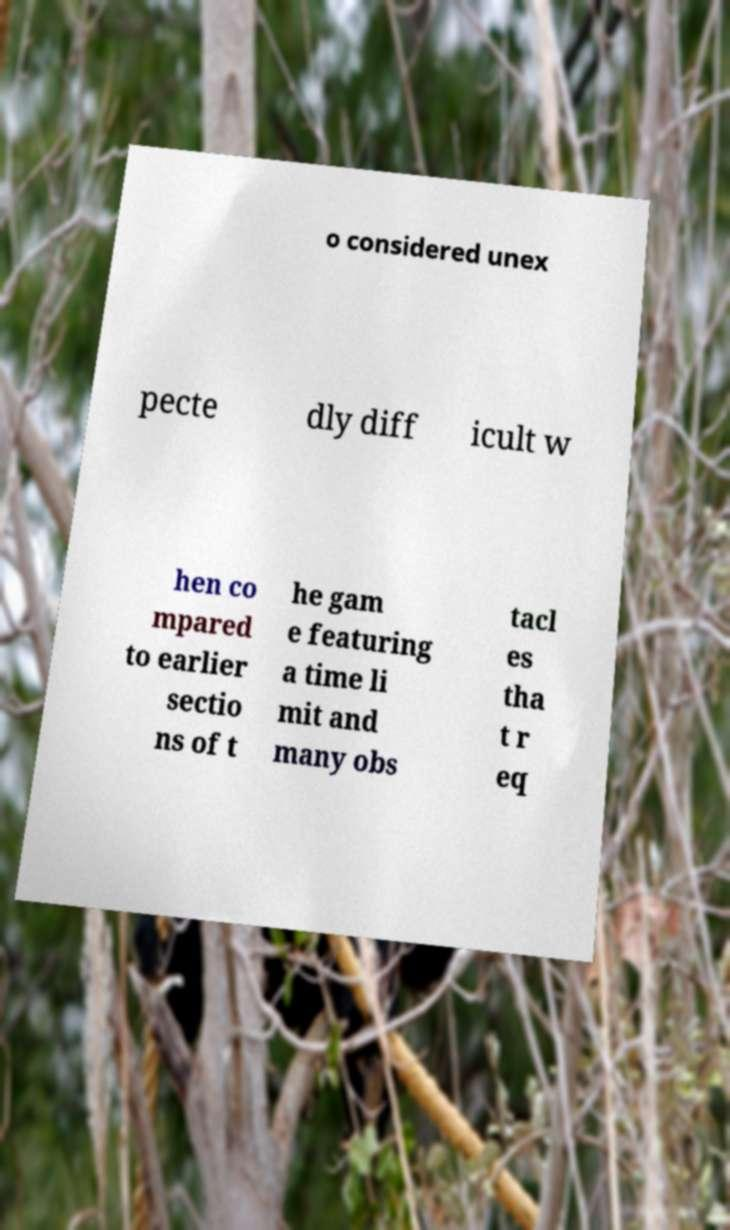Could you assist in decoding the text presented in this image and type it out clearly? o considered unex pecte dly diff icult w hen co mpared to earlier sectio ns of t he gam e featuring a time li mit and many obs tacl es tha t r eq 